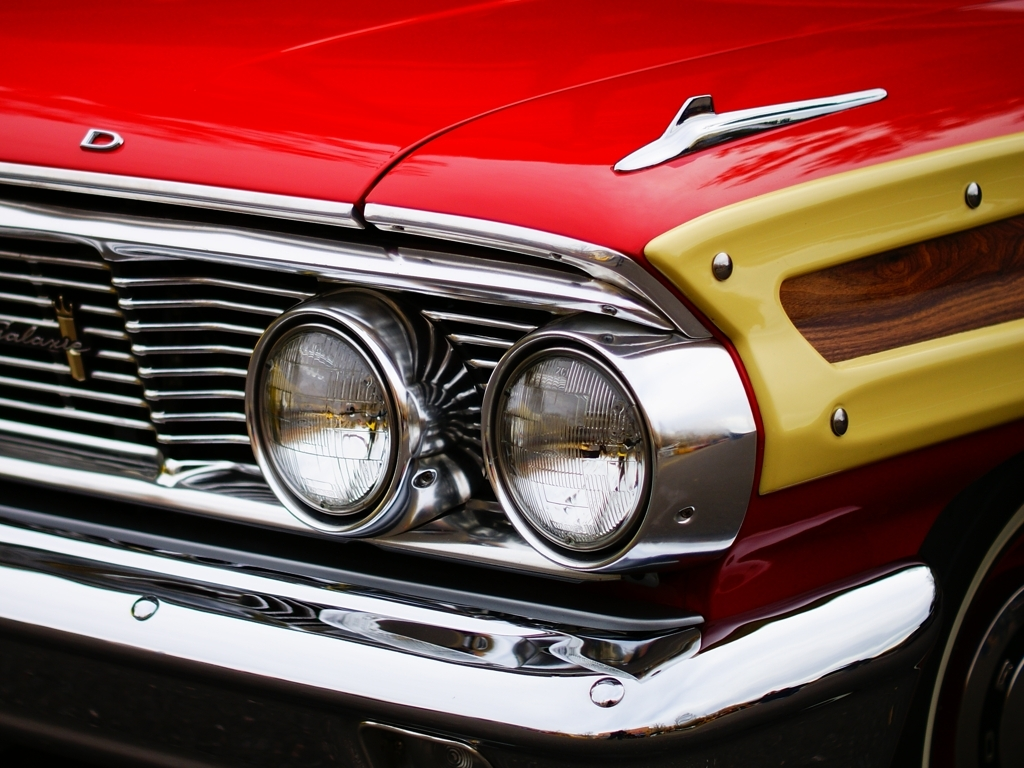How would you describe the details of the front end of the car?
A. The details of the front end of the car are presented very well with a good sense of texture.
B. The details of the front end of the car are exaggerated.
C. The details of the front end of the car are poorly captured.
Answer with the option's letter from the given choices directly.
 A. 